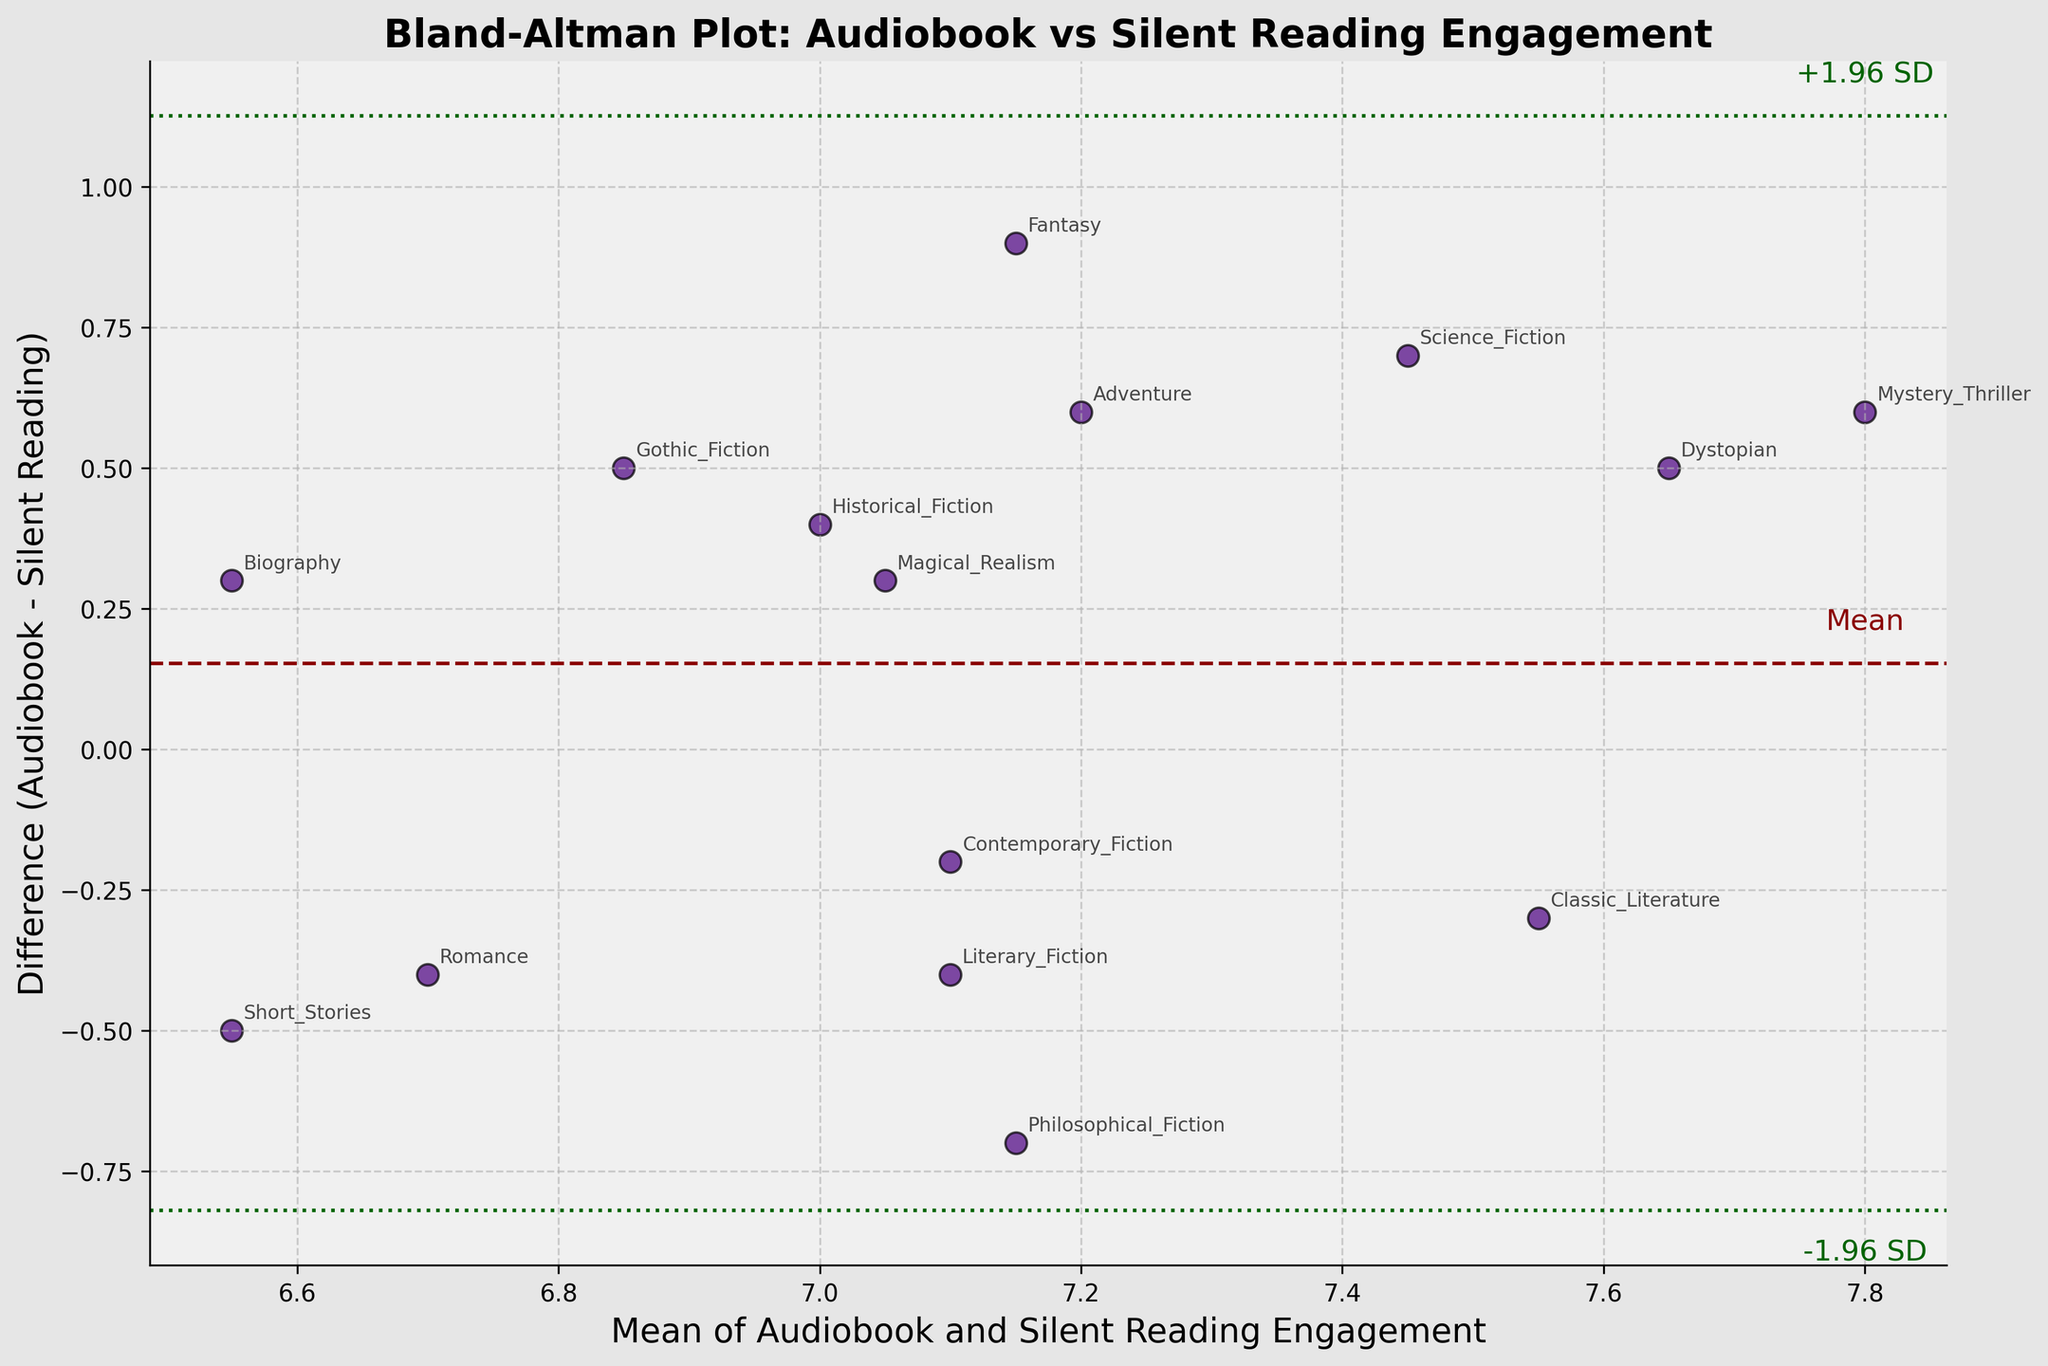What is the title of the plot? The title is usually found at the top of the plot, clearly indicating what the plot represents.
Answer: Bland-Altman Plot: Audiobook vs Silent Reading Engagement How many narrative styles are annotated on the plot? Each data point on the plot represents a narrative style, which is annotated with its name. By counting these annotations, we can determine the number of narrative styles.
Answer: 15 What is the mean difference indicated by the dashed horizontal line? The dashed horizontal line represents the mean difference between audiobook and silent reading engagement levels. This value is labeled near the line.
Answer: -0.040 Which narrative style had the highest engagement difference favoring audiobooks? By examining the data points, the one furthest above the horizontal means audiobooks had higher engagement. Locate this point and its annotation.
Answer: Mystery Thriller Are there more narrative styles with higher engagement in silent reading or audiobooks? Compare the number of points above and below the mean difference line. Points above indicate higher audiobook engagement and below indicate higher silent reading engagement. More high silent readings mean more points below.
Answer: Silent reading What is the upper limit of agreement (+1.96 SD) for this plot? The upper limit of agreement is shown as a dotted line above the mean difference line, often labeled.
Answer: 0.75 Calculate the difference in engagement between audiobooks and silent reading for "Historical Fiction.” Using the data, subtract the silent reading engagement from the audiobook engagement for "Historical Fiction."
Answer: 0.4 What is the mean engagement value for "Romance"? The mean engagement value is the average of the audiobook and silent reading engagement values for "Romance." (6.5 + 6.9) / 2
Answer: 6.7 Which narrative style is closest to the mean difference line, suggesting similar engagement in both formats? Identify the point nearest to the mean difference line. The closer the point, the smaller the engagement difference.
Answer: Biography Among the points with the largest difference from the mean, what narrative style shows a high positive deviation? Look for the points furthest from the mean difference line on the positive side and identify the annotated narrative style.
Answer: Gothic Fiction 